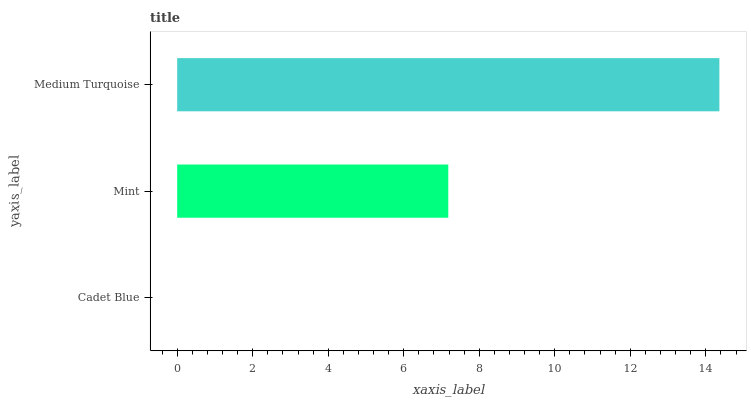Is Cadet Blue the minimum?
Answer yes or no. Yes. Is Medium Turquoise the maximum?
Answer yes or no. Yes. Is Mint the minimum?
Answer yes or no. No. Is Mint the maximum?
Answer yes or no. No. Is Mint greater than Cadet Blue?
Answer yes or no. Yes. Is Cadet Blue less than Mint?
Answer yes or no. Yes. Is Cadet Blue greater than Mint?
Answer yes or no. No. Is Mint less than Cadet Blue?
Answer yes or no. No. Is Mint the high median?
Answer yes or no. Yes. Is Mint the low median?
Answer yes or no. Yes. Is Cadet Blue the high median?
Answer yes or no. No. Is Cadet Blue the low median?
Answer yes or no. No. 